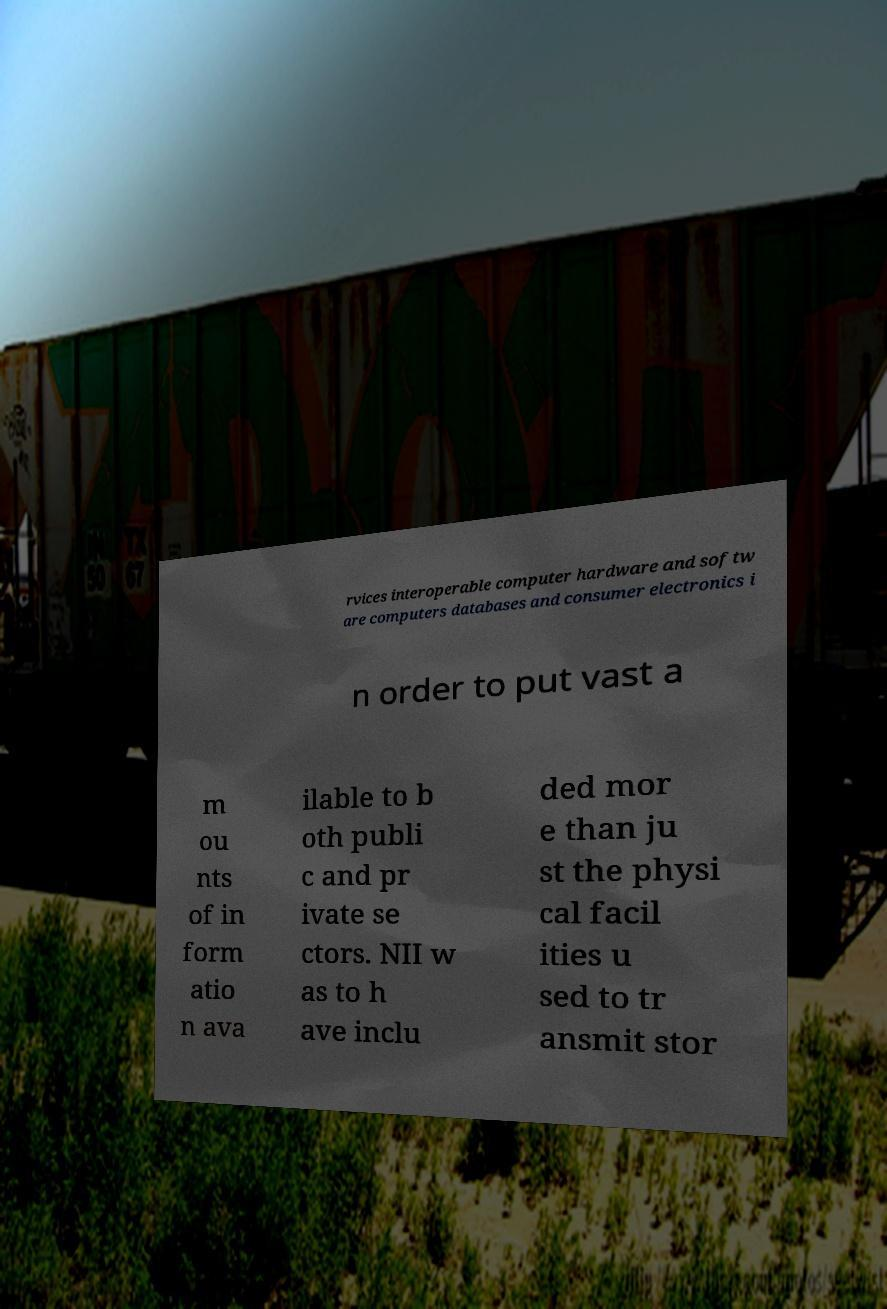Could you extract and type out the text from this image? rvices interoperable computer hardware and softw are computers databases and consumer electronics i n order to put vast a m ou nts of in form atio n ava ilable to b oth publi c and pr ivate se ctors. NII w as to h ave inclu ded mor e than ju st the physi cal facil ities u sed to tr ansmit stor 